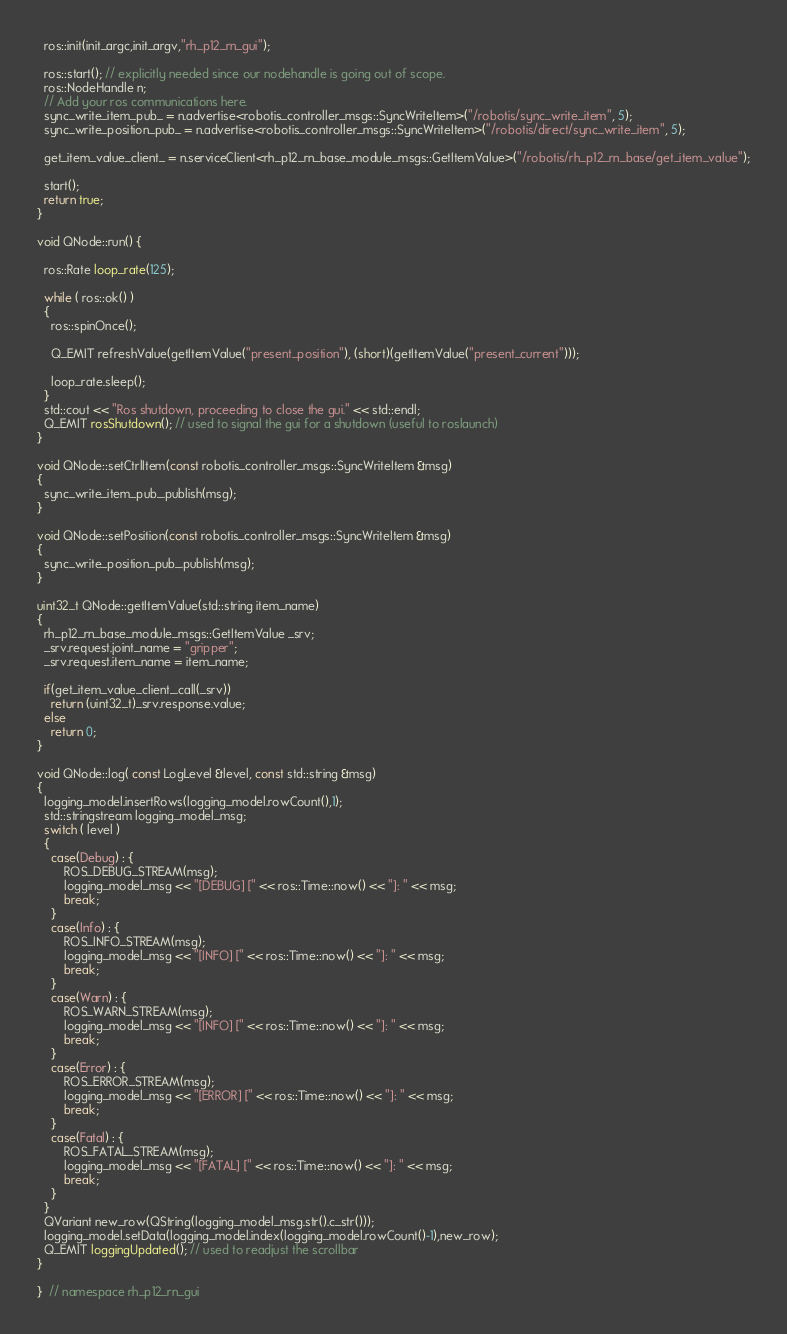<code> <loc_0><loc_0><loc_500><loc_500><_C++_>  ros::init(init_argc,init_argv,"rh_p12_rn_gui");

  ros::start(); // explicitly needed since our nodehandle is going out of scope.
  ros::NodeHandle n;
  // Add your ros communications here.
  sync_write_item_pub_ = n.advertise<robotis_controller_msgs::SyncWriteItem>("/robotis/sync_write_item", 5);
  sync_write_position_pub_ = n.advertise<robotis_controller_msgs::SyncWriteItem>("/robotis/direct/sync_write_item", 5);

  get_item_value_client_ = n.serviceClient<rh_p12_rn_base_module_msgs::GetItemValue>("/robotis/rh_p12_rn_base/get_item_value");

  start();
  return true;
}

void QNode::run() {

  ros::Rate loop_rate(125);

  while ( ros::ok() )
  {
    ros::spinOnce();

    Q_EMIT refreshValue(getItemValue("present_position"), (short)(getItemValue("present_current")));

    loop_rate.sleep();
  }
  std::cout << "Ros shutdown, proceeding to close the gui." << std::endl;
  Q_EMIT rosShutdown(); // used to signal the gui for a shutdown (useful to roslaunch)
}

void QNode::setCtrlItem(const robotis_controller_msgs::SyncWriteItem &msg)
{
  sync_write_item_pub_.publish(msg);
}

void QNode::setPosition(const robotis_controller_msgs::SyncWriteItem &msg)
{
  sync_write_position_pub_.publish(msg);
}

uint32_t QNode::getItemValue(std::string item_name)
{
  rh_p12_rn_base_module_msgs::GetItemValue _srv;
  _srv.request.joint_name = "gripper";
  _srv.request.item_name = item_name;

  if(get_item_value_client_.call(_srv))
    return (uint32_t)_srv.response.value;
  else
    return 0;
}

void QNode::log( const LogLevel &level, const std::string &msg)
{
  logging_model.insertRows(logging_model.rowCount(),1);
  std::stringstream logging_model_msg;
  switch ( level )
  {
    case(Debug) : {
        ROS_DEBUG_STREAM(msg);
        logging_model_msg << "[DEBUG] [" << ros::Time::now() << "]: " << msg;
        break;
    }
    case(Info) : {
        ROS_INFO_STREAM(msg);
        logging_model_msg << "[INFO] [" << ros::Time::now() << "]: " << msg;
        break;
    }
    case(Warn) : {
        ROS_WARN_STREAM(msg);
        logging_model_msg << "[INFO] [" << ros::Time::now() << "]: " << msg;
        break;
    }
    case(Error) : {
        ROS_ERROR_STREAM(msg);
        logging_model_msg << "[ERROR] [" << ros::Time::now() << "]: " << msg;
        break;
    }
    case(Fatal) : {
        ROS_FATAL_STREAM(msg);
        logging_model_msg << "[FATAL] [" << ros::Time::now() << "]: " << msg;
        break;
    }
  }
  QVariant new_row(QString(logging_model_msg.str().c_str()));
  logging_model.setData(logging_model.index(logging_model.rowCount()-1),new_row);
  Q_EMIT loggingUpdated(); // used to readjust the scrollbar
}

}  // namespace rh_p12_rn_gui
</code> 